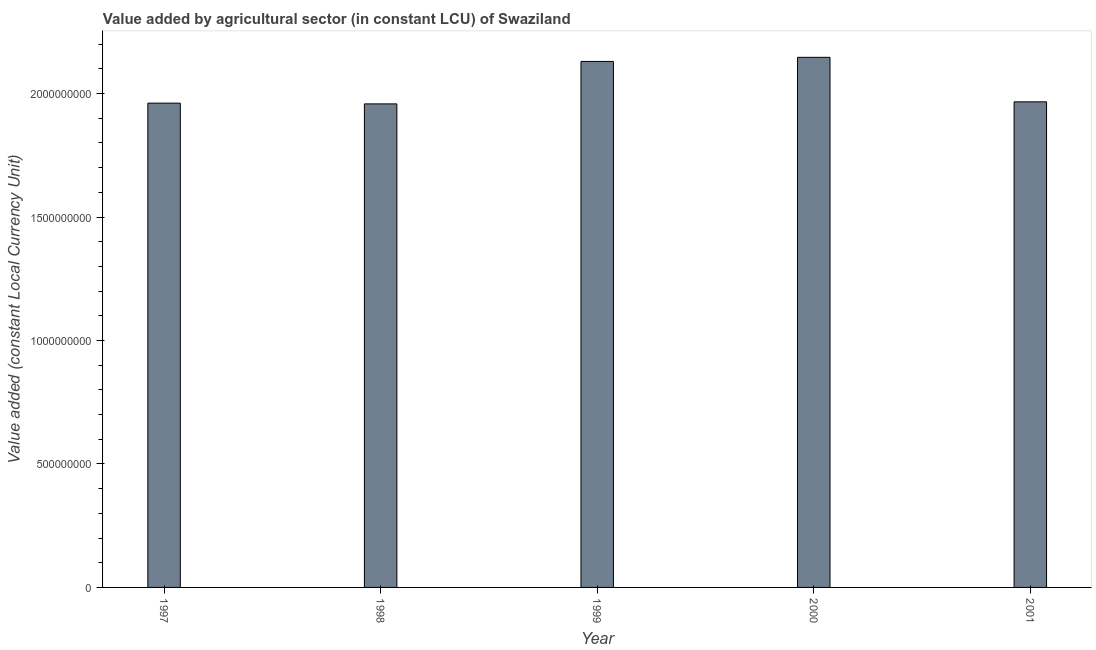Does the graph contain any zero values?
Ensure brevity in your answer.  No. Does the graph contain grids?
Provide a short and direct response. No. What is the title of the graph?
Offer a terse response. Value added by agricultural sector (in constant LCU) of Swaziland. What is the label or title of the X-axis?
Provide a short and direct response. Year. What is the label or title of the Y-axis?
Give a very brief answer. Value added (constant Local Currency Unit). What is the value added by agriculture sector in 1999?
Make the answer very short. 2.13e+09. Across all years, what is the maximum value added by agriculture sector?
Make the answer very short. 2.15e+09. Across all years, what is the minimum value added by agriculture sector?
Make the answer very short. 1.96e+09. In which year was the value added by agriculture sector maximum?
Your answer should be compact. 2000. In which year was the value added by agriculture sector minimum?
Make the answer very short. 1998. What is the sum of the value added by agriculture sector?
Ensure brevity in your answer.  1.02e+1. What is the difference between the value added by agriculture sector in 1998 and 2000?
Ensure brevity in your answer.  -1.89e+08. What is the average value added by agriculture sector per year?
Your response must be concise. 2.03e+09. What is the median value added by agriculture sector?
Your response must be concise. 1.97e+09. In how many years, is the value added by agriculture sector greater than 1400000000 LCU?
Provide a short and direct response. 5. What is the ratio of the value added by agriculture sector in 1999 to that in 2001?
Ensure brevity in your answer.  1.08. Is the value added by agriculture sector in 1998 less than that in 2001?
Your answer should be compact. Yes. Is the difference between the value added by agriculture sector in 1999 and 2000 greater than the difference between any two years?
Your answer should be very brief. No. What is the difference between the highest and the second highest value added by agriculture sector?
Make the answer very short. 1.66e+07. Is the sum of the value added by agriculture sector in 1997 and 2000 greater than the maximum value added by agriculture sector across all years?
Offer a very short reply. Yes. What is the difference between the highest and the lowest value added by agriculture sector?
Offer a terse response. 1.89e+08. In how many years, is the value added by agriculture sector greater than the average value added by agriculture sector taken over all years?
Keep it short and to the point. 2. How many bars are there?
Ensure brevity in your answer.  5. How many years are there in the graph?
Give a very brief answer. 5. Are the values on the major ticks of Y-axis written in scientific E-notation?
Keep it short and to the point. No. What is the Value added (constant Local Currency Unit) of 1997?
Ensure brevity in your answer.  1.96e+09. What is the Value added (constant Local Currency Unit) of 1998?
Ensure brevity in your answer.  1.96e+09. What is the Value added (constant Local Currency Unit) in 1999?
Ensure brevity in your answer.  2.13e+09. What is the Value added (constant Local Currency Unit) of 2000?
Your answer should be compact. 2.15e+09. What is the Value added (constant Local Currency Unit) of 2001?
Give a very brief answer. 1.97e+09. What is the difference between the Value added (constant Local Currency Unit) in 1997 and 1998?
Your response must be concise. 3.04e+06. What is the difference between the Value added (constant Local Currency Unit) in 1997 and 1999?
Offer a terse response. -1.69e+08. What is the difference between the Value added (constant Local Currency Unit) in 1997 and 2000?
Your answer should be compact. -1.85e+08. What is the difference between the Value added (constant Local Currency Unit) in 1997 and 2001?
Your answer should be compact. -5.27e+06. What is the difference between the Value added (constant Local Currency Unit) in 1998 and 1999?
Give a very brief answer. -1.72e+08. What is the difference between the Value added (constant Local Currency Unit) in 1998 and 2000?
Your response must be concise. -1.89e+08. What is the difference between the Value added (constant Local Currency Unit) in 1998 and 2001?
Your answer should be compact. -8.30e+06. What is the difference between the Value added (constant Local Currency Unit) in 1999 and 2000?
Give a very brief answer. -1.66e+07. What is the difference between the Value added (constant Local Currency Unit) in 1999 and 2001?
Ensure brevity in your answer.  1.64e+08. What is the difference between the Value added (constant Local Currency Unit) in 2000 and 2001?
Keep it short and to the point. 1.80e+08. What is the ratio of the Value added (constant Local Currency Unit) in 1997 to that in 1999?
Your response must be concise. 0.92. What is the ratio of the Value added (constant Local Currency Unit) in 1997 to that in 2000?
Give a very brief answer. 0.91. What is the ratio of the Value added (constant Local Currency Unit) in 1998 to that in 1999?
Offer a very short reply. 0.92. What is the ratio of the Value added (constant Local Currency Unit) in 1998 to that in 2000?
Provide a succinct answer. 0.91. What is the ratio of the Value added (constant Local Currency Unit) in 1998 to that in 2001?
Ensure brevity in your answer.  1. What is the ratio of the Value added (constant Local Currency Unit) in 1999 to that in 2001?
Your response must be concise. 1.08. What is the ratio of the Value added (constant Local Currency Unit) in 2000 to that in 2001?
Your answer should be compact. 1.09. 